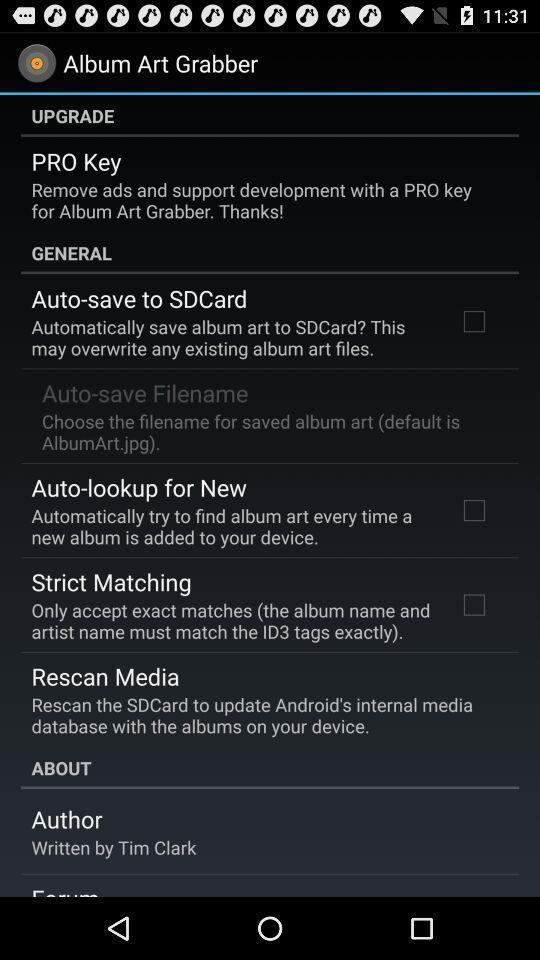Explain what's happening in this screen capture. Various options in a album art app. 